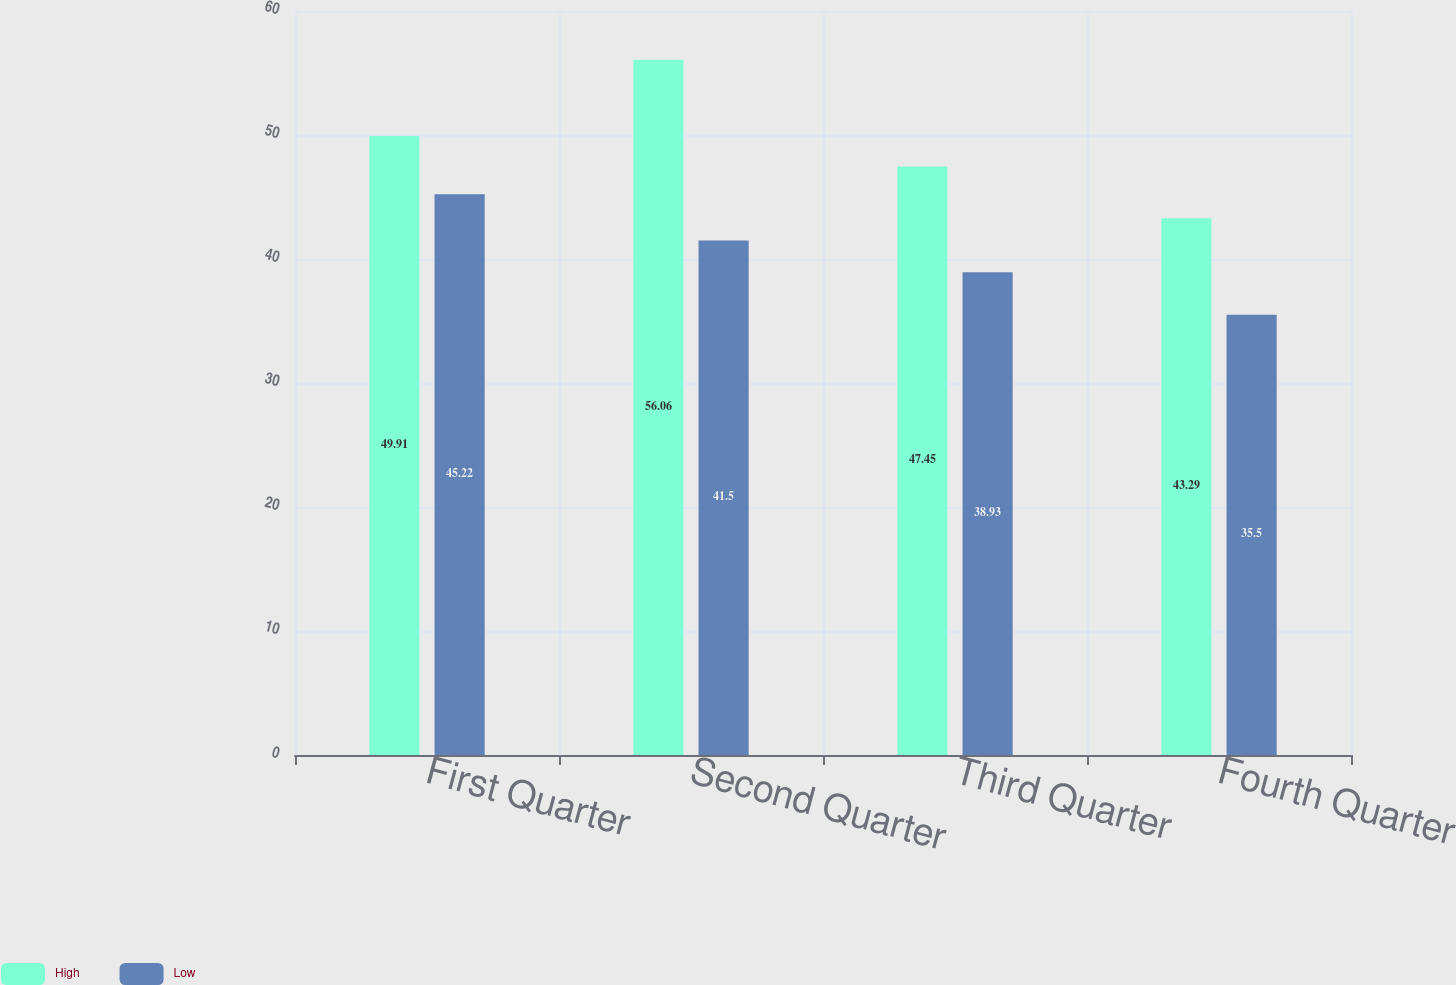<chart> <loc_0><loc_0><loc_500><loc_500><stacked_bar_chart><ecel><fcel>First Quarter<fcel>Second Quarter<fcel>Third Quarter<fcel>Fourth Quarter<nl><fcel>High<fcel>49.91<fcel>56.06<fcel>47.45<fcel>43.29<nl><fcel>Low<fcel>45.22<fcel>41.5<fcel>38.93<fcel>35.5<nl></chart> 